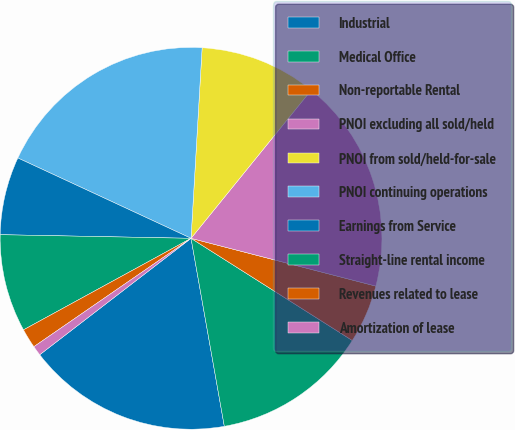Convert chart to OTSL. <chart><loc_0><loc_0><loc_500><loc_500><pie_chart><fcel>Industrial<fcel>Medical Office<fcel>Non-reportable Rental<fcel>PNOI excluding all sold/held<fcel>PNOI from sold/held-for-sale<fcel>PNOI continuing operations<fcel>Earnings from Service<fcel>Straight-line rental income<fcel>Revenues related to lease<fcel>Amortization of lease<nl><fcel>17.35%<fcel>13.22%<fcel>4.96%<fcel>18.18%<fcel>9.92%<fcel>19.01%<fcel>6.61%<fcel>8.26%<fcel>1.65%<fcel>0.83%<nl></chart> 